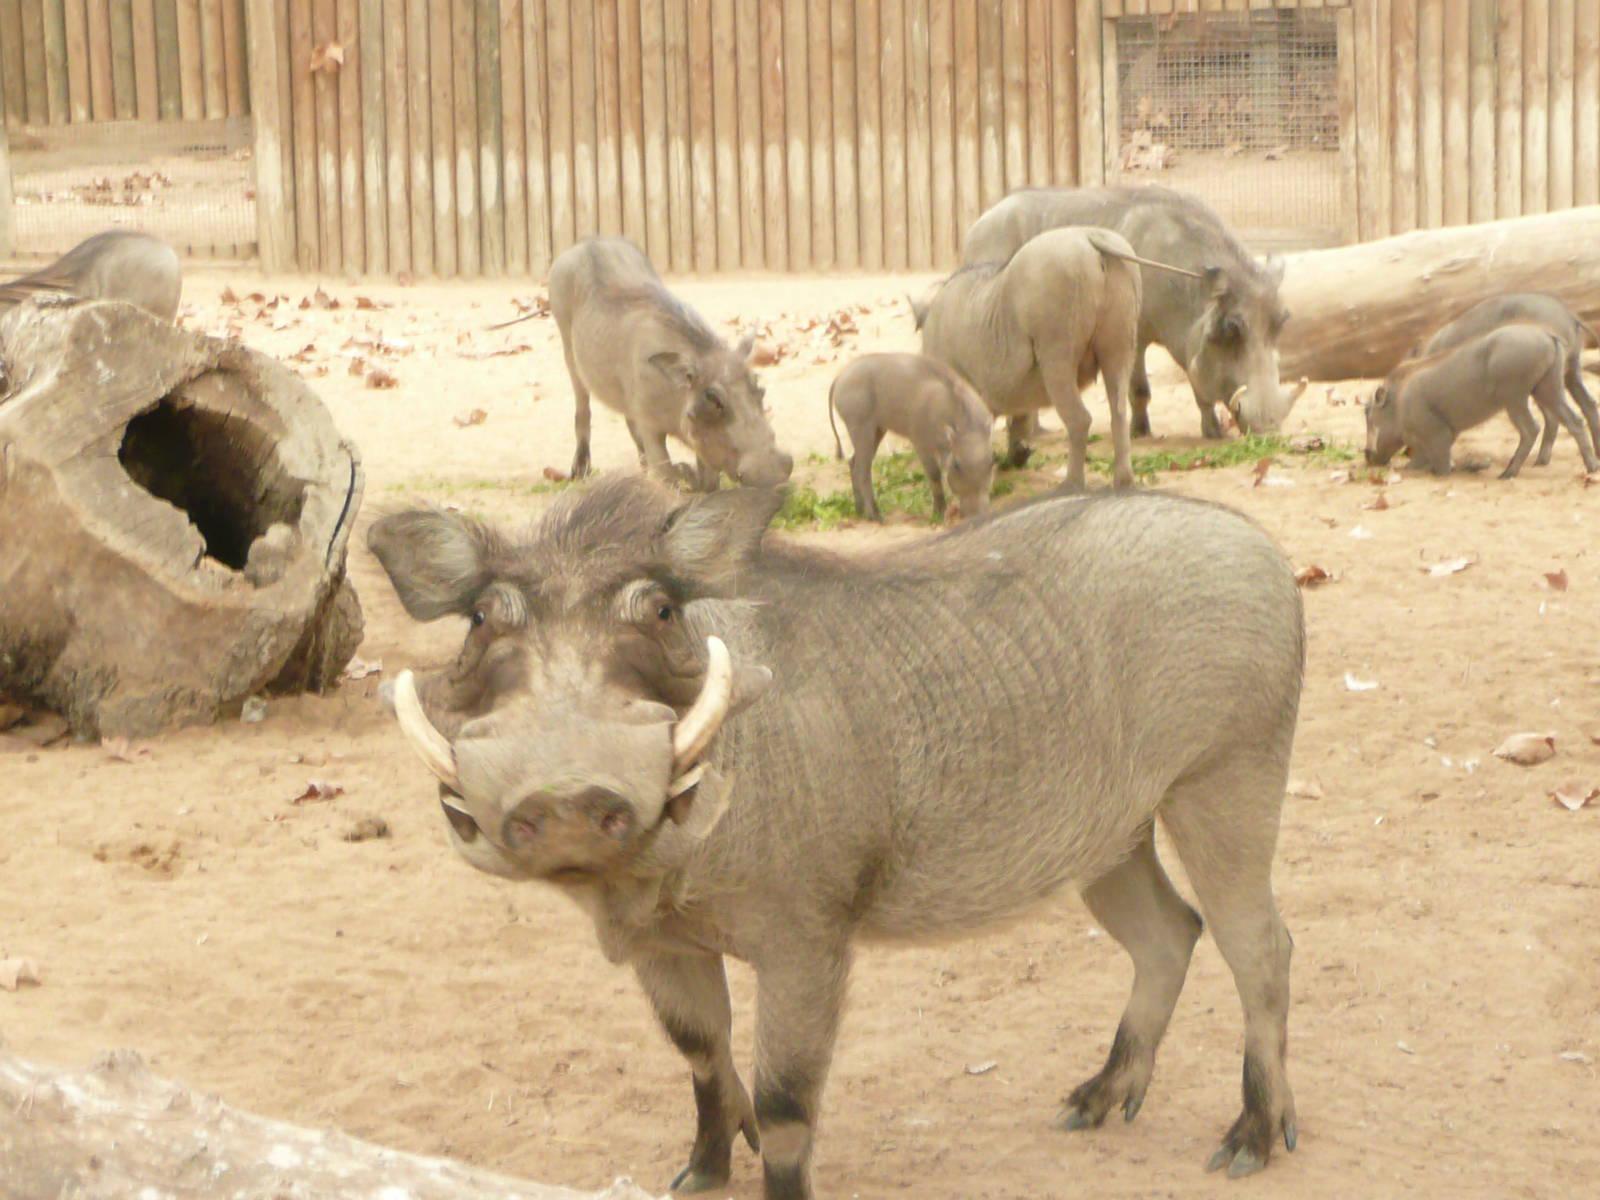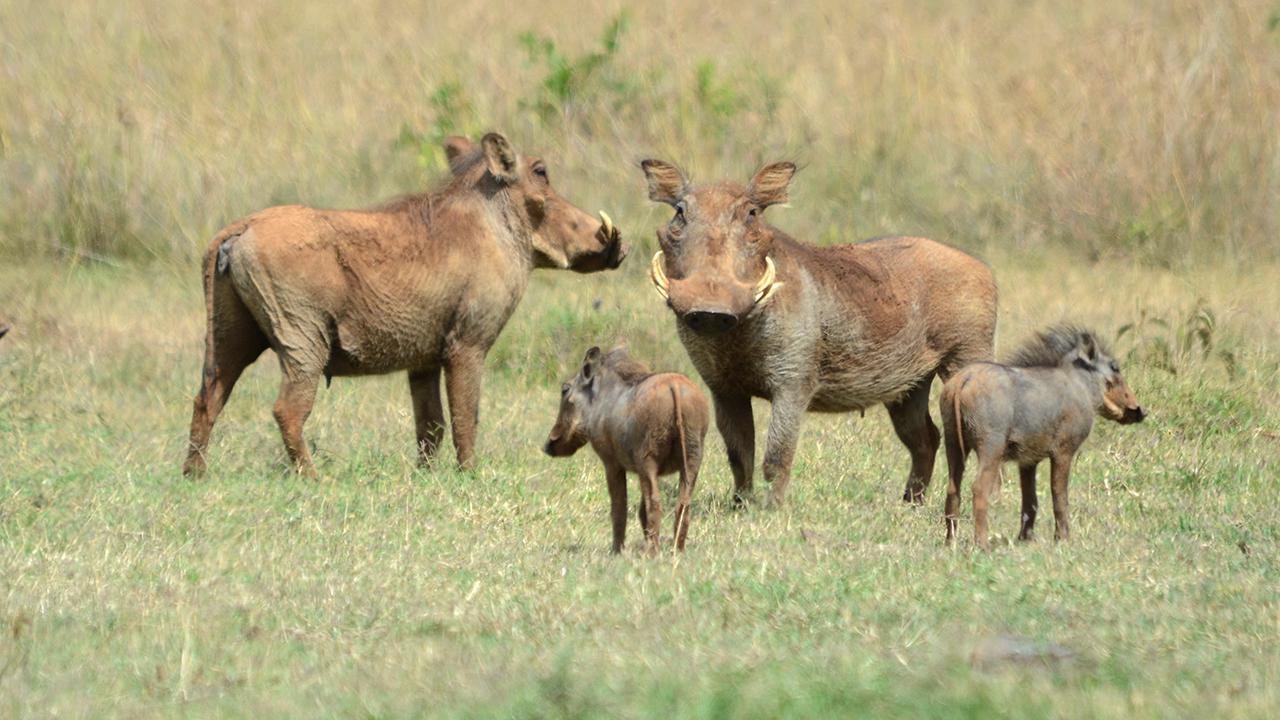The first image is the image on the left, the second image is the image on the right. Given the left and right images, does the statement "There are exactly five animals in the image on the right." hold true? Answer yes or no. No. 